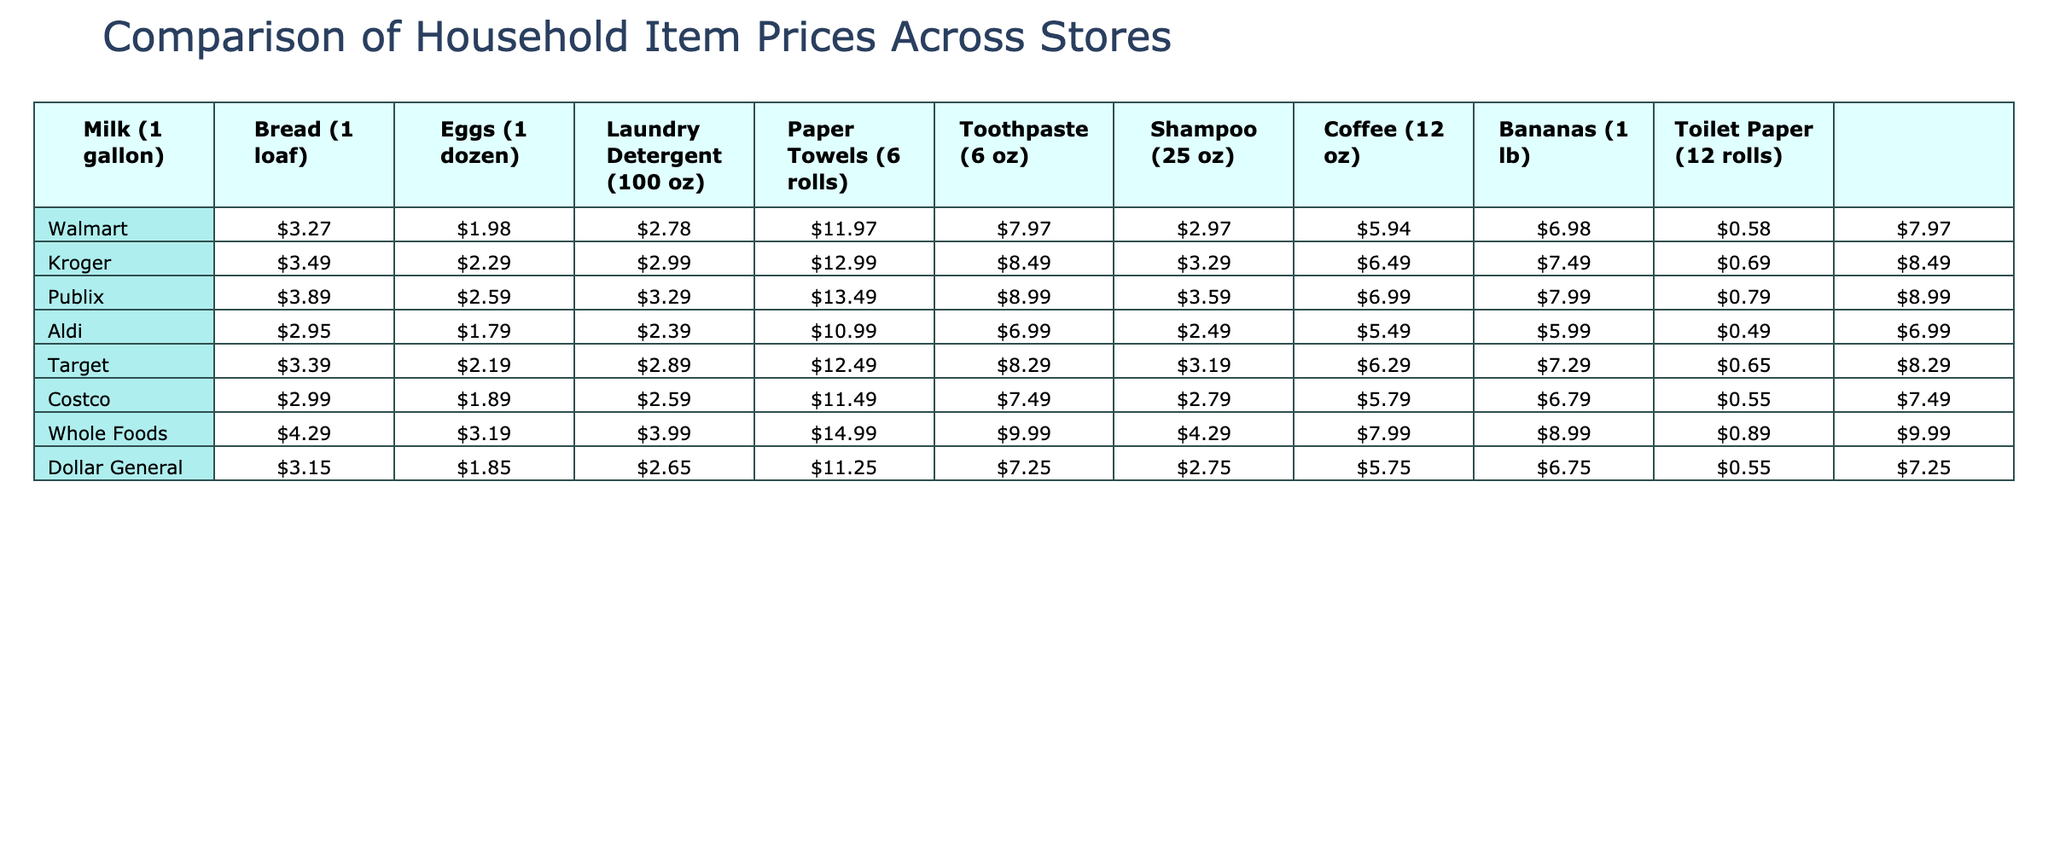What is the price of a loaf of bread at Aldi? According to the table, the price for a loaf of bread at Aldi is listed directly under the Aldi column in the Bread row. That value is 1.79.
Answer: 1.79 Which store has the cheapest milk? From the table, we can see the prices for milk at each store and compare them. The lowest price listed for milk is 2.95 at Aldi.
Answer: Aldi How much do paper towels cost at Costco? The table shows the price for paper towels at Costco in the corresponding column and row, which is 7.49.
Answer: 7.49 Is the cost of eggs the same at Walmart and Target? By checking the prices of eggs at both Walmart (2.78) and Target (2.89) in the table, we can see that the prices are different. Therefore, they are not the same.
Answer: No What is the total cost of a gallon of milk, a dozen eggs, and a loaf of bread at Kroger? First, find the prices in the table: Milk at Kroger is 3.49, Eggs are 2.99, and Bread is 2.29. We sum these values: 3.49 + 2.99 + 2.29 = 8.77.
Answer: 8.77 Which store offers the most expensive laundry detergent? The prices for laundry detergent are found in the corresponding column under each store. The highest price is found at Whole Foods, which is 14.99.
Answer: Whole Foods What is the average price of shampoo across all stores? The prices for shampoo can be summed as follows: 5.94 + 6.49 + 6.99 + 5.49 + 6.29 + 5.79 + 7.99 + 7.49 = 52.46. There are 8 stores, so now divide that by 8: 52.46 / 8 = 6.56.
Answer: 6.56 Which store has the lowest price for bananas? The prices of bananas are compared across all stores, and the lowest price can be found under the Bananas row. The cheapest price is at Aldi, which is 0.49.
Answer: Aldi Is the price for Toilet Paper at Dollar General lower than at Walmart? The price for Toilet Paper at Dollar General is 7.25, while at Walmart it is 7.97. Since 7.25 is less than 7.97, Dollar General has a lower price.
Answer: Yes What is the difference in price for Laundry Detergent between Walmart and Whole Foods? The price for Laundry Detergent at Walmart is 11.97, and at Whole Foods, it is 14.99. To find the difference, subtract: 14.99 - 11.97 = 3.02.
Answer: 3.02 